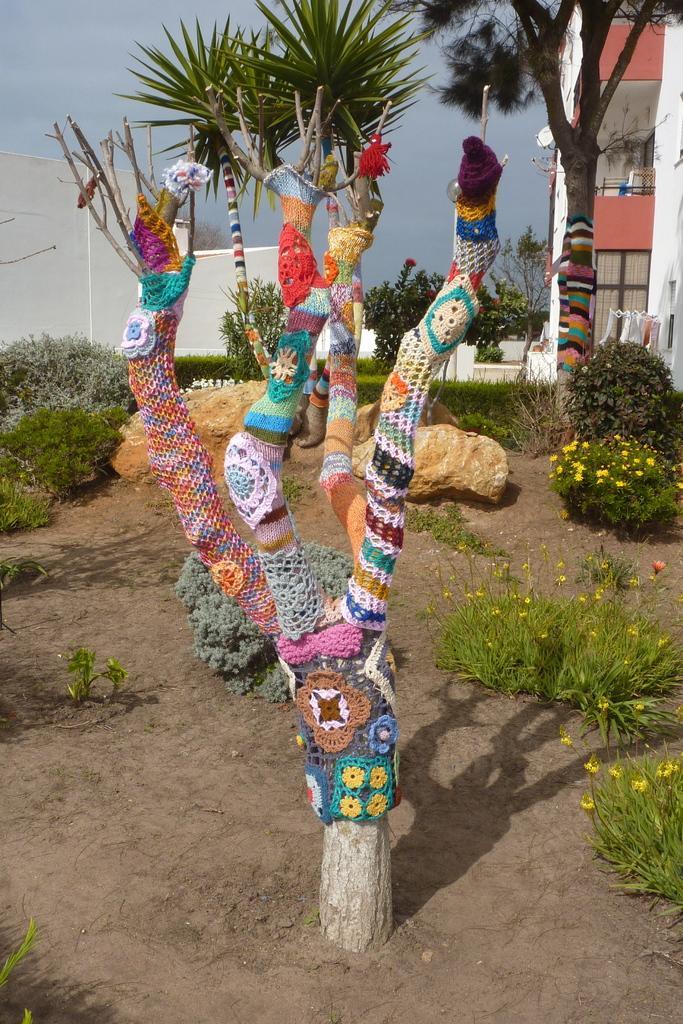Could you give a brief overview of what you see in this image? In this image I can see a dried tree to which I can see number of clothes are attached. I can see the ground, few plants, few flowers which are yellow and pink in color. In the background I can see few buildings, few trees and the sky. 